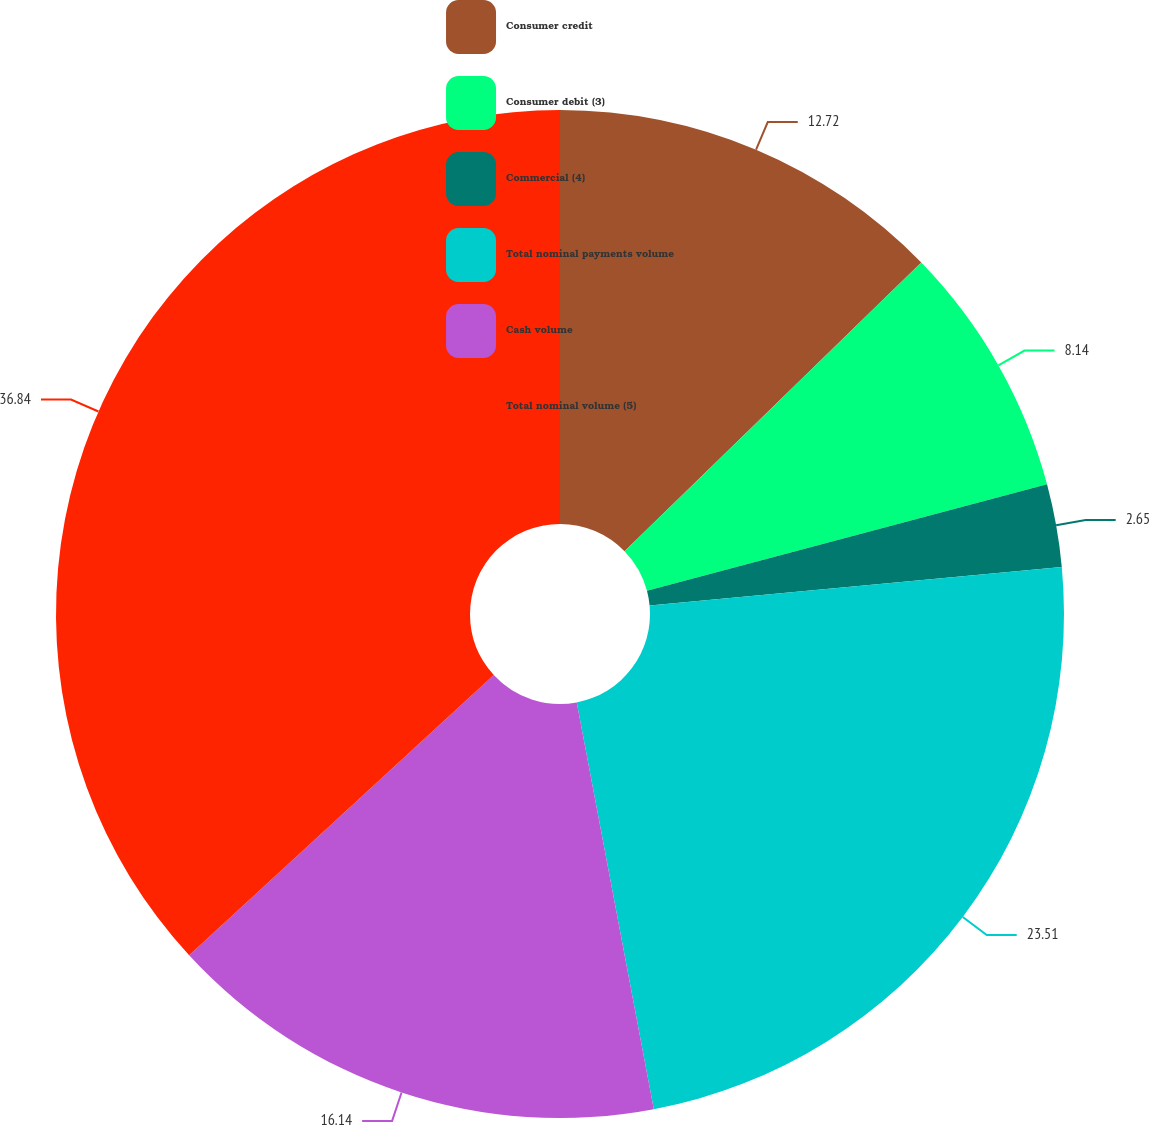<chart> <loc_0><loc_0><loc_500><loc_500><pie_chart><fcel>Consumer credit<fcel>Consumer debit (3)<fcel>Commercial (4)<fcel>Total nominal payments volume<fcel>Cash volume<fcel>Total nominal volume (5)<nl><fcel>12.72%<fcel>8.14%<fcel>2.65%<fcel>23.51%<fcel>16.14%<fcel>36.84%<nl></chart> 